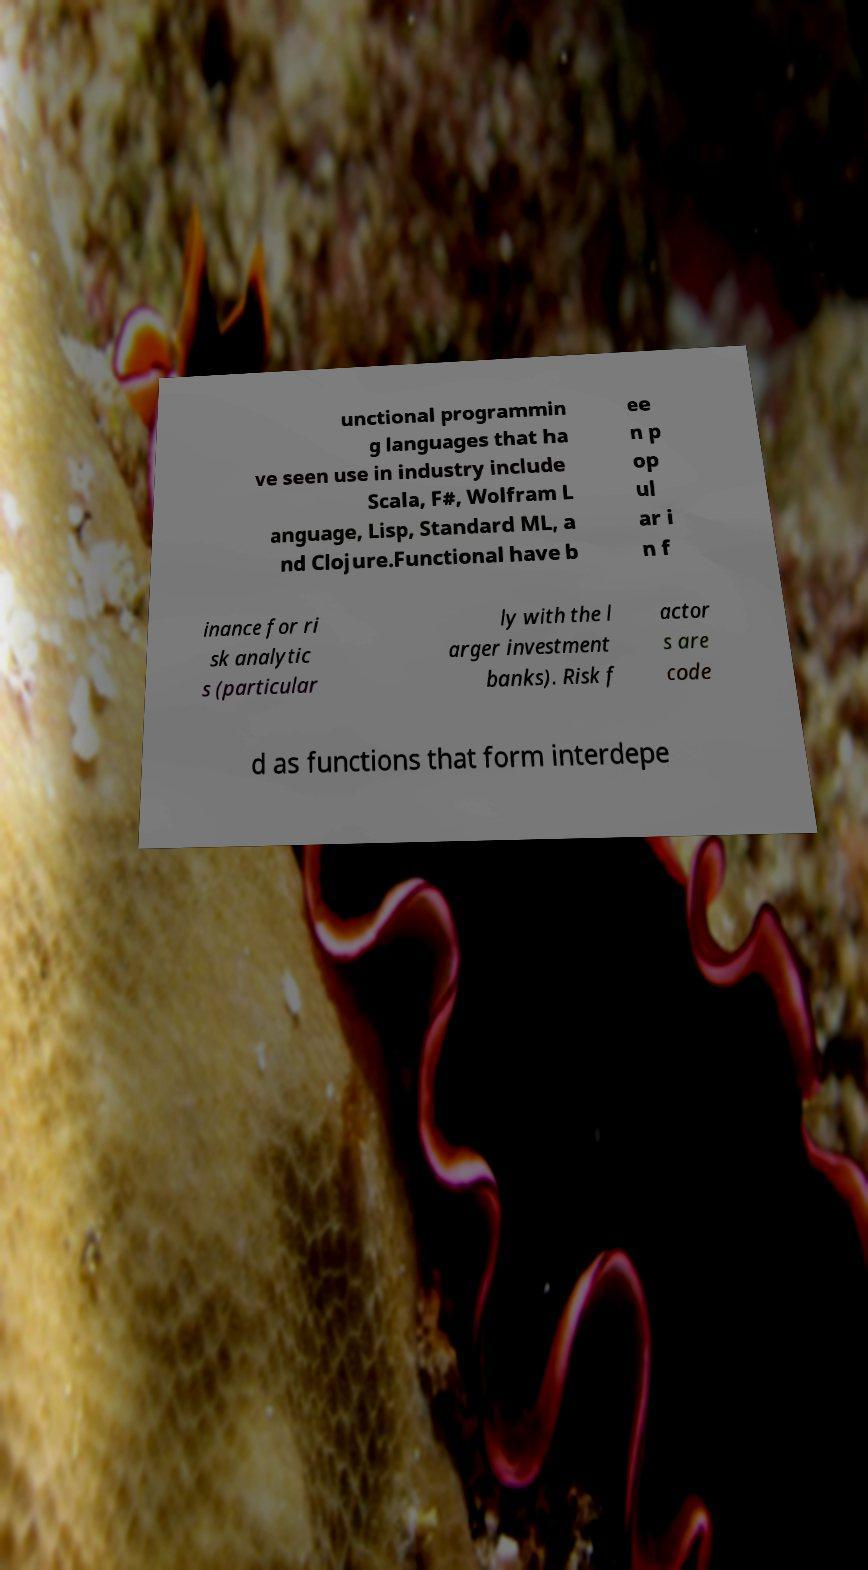Could you assist in decoding the text presented in this image and type it out clearly? unctional programmin g languages that ha ve seen use in industry include Scala, F#, Wolfram L anguage, Lisp, Standard ML, a nd Clojure.Functional have b ee n p op ul ar i n f inance for ri sk analytic s (particular ly with the l arger investment banks). Risk f actor s are code d as functions that form interdepe 